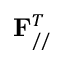Convert formula to latex. <formula><loc_0><loc_0><loc_500><loc_500>F _ { / / } ^ { T }</formula> 